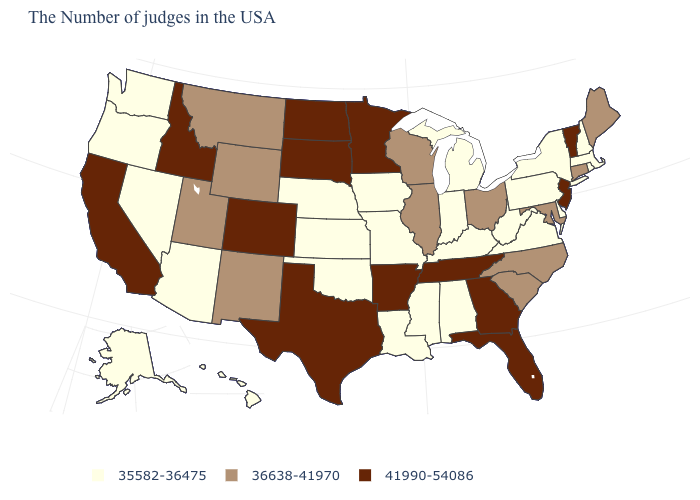Does Kansas have the highest value in the USA?
Keep it brief. No. What is the value of Pennsylvania?
Concise answer only. 35582-36475. Among the states that border Oregon , which have the highest value?
Short answer required. Idaho, California. Which states have the lowest value in the USA?
Quick response, please. Massachusetts, Rhode Island, New Hampshire, New York, Delaware, Pennsylvania, Virginia, West Virginia, Michigan, Kentucky, Indiana, Alabama, Mississippi, Louisiana, Missouri, Iowa, Kansas, Nebraska, Oklahoma, Arizona, Nevada, Washington, Oregon, Alaska, Hawaii. Which states have the highest value in the USA?
Write a very short answer. Vermont, New Jersey, Florida, Georgia, Tennessee, Arkansas, Minnesota, Texas, South Dakota, North Dakota, Colorado, Idaho, California. Name the states that have a value in the range 41990-54086?
Keep it brief. Vermont, New Jersey, Florida, Georgia, Tennessee, Arkansas, Minnesota, Texas, South Dakota, North Dakota, Colorado, Idaho, California. What is the lowest value in the West?
Concise answer only. 35582-36475. What is the value of Delaware?
Keep it brief. 35582-36475. Is the legend a continuous bar?
Keep it brief. No. Which states have the lowest value in the MidWest?
Concise answer only. Michigan, Indiana, Missouri, Iowa, Kansas, Nebraska. What is the value of New York?
Answer briefly. 35582-36475. Which states have the lowest value in the MidWest?
Concise answer only. Michigan, Indiana, Missouri, Iowa, Kansas, Nebraska. Name the states that have a value in the range 41990-54086?
Answer briefly. Vermont, New Jersey, Florida, Georgia, Tennessee, Arkansas, Minnesota, Texas, South Dakota, North Dakota, Colorado, Idaho, California. What is the highest value in the USA?
Quick response, please. 41990-54086. What is the value of Ohio?
Answer briefly. 36638-41970. 